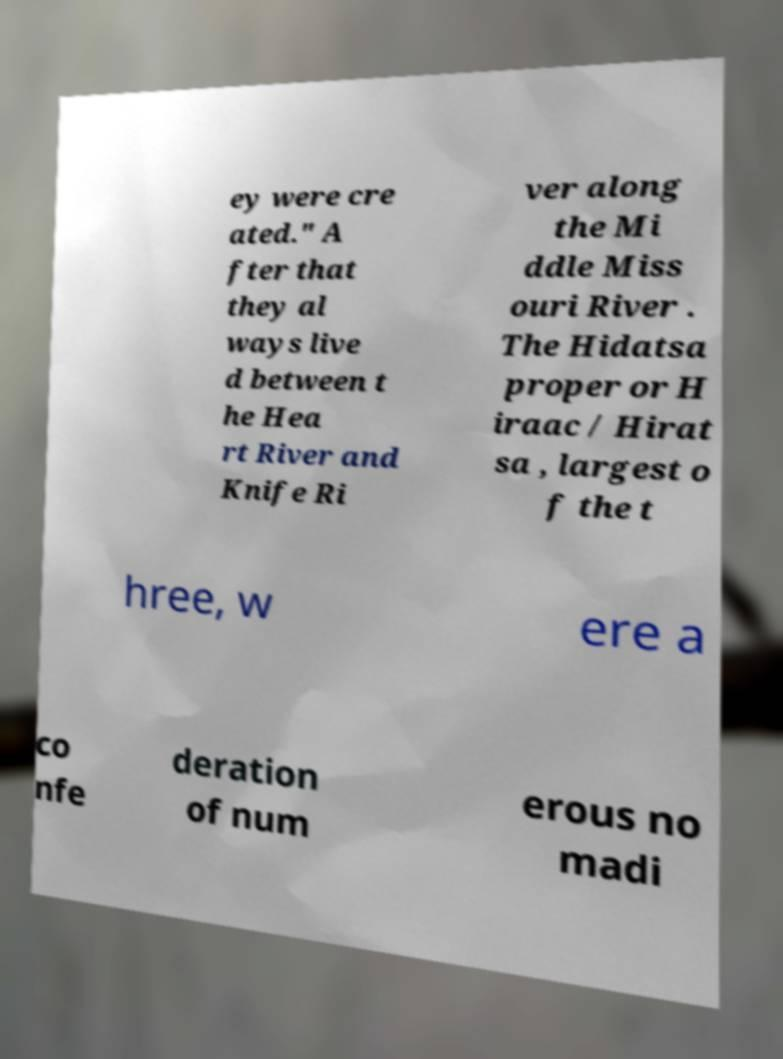For documentation purposes, I need the text within this image transcribed. Could you provide that? ey were cre ated." A fter that they al ways live d between t he Hea rt River and Knife Ri ver along the Mi ddle Miss ouri River . The Hidatsa proper or H iraac / Hirat sa , largest o f the t hree, w ere a co nfe deration of num erous no madi 